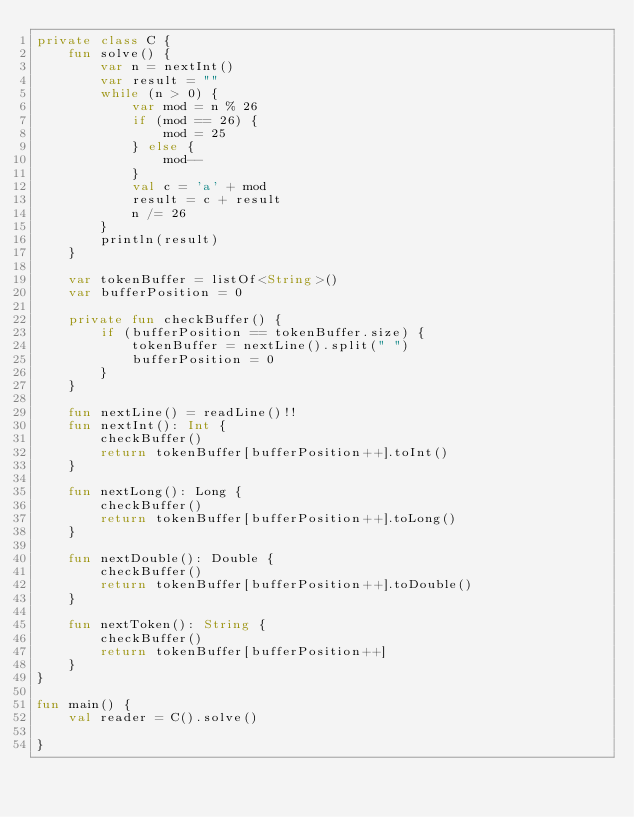<code> <loc_0><loc_0><loc_500><loc_500><_Kotlin_>private class C {
    fun solve() {
        var n = nextInt()
        var result = ""
        while (n > 0) {
            var mod = n % 26
            if (mod == 26) {
                mod = 25
            } else {
                mod--
            }
            val c = 'a' + mod
            result = c + result
            n /= 26
        }
        println(result)
    }

    var tokenBuffer = listOf<String>()
    var bufferPosition = 0

    private fun checkBuffer() {
        if (bufferPosition == tokenBuffer.size) {
            tokenBuffer = nextLine().split(" ")
            bufferPosition = 0
        }
    }

    fun nextLine() = readLine()!!
    fun nextInt(): Int {
        checkBuffer()
        return tokenBuffer[bufferPosition++].toInt()
    }

    fun nextLong(): Long {
        checkBuffer()
        return tokenBuffer[bufferPosition++].toLong()
    }

    fun nextDouble(): Double {
        checkBuffer()
        return tokenBuffer[bufferPosition++].toDouble()
    }

    fun nextToken(): String {
        checkBuffer()
        return tokenBuffer[bufferPosition++]
    }
}

fun main() {
    val reader = C().solve()

}
</code> 